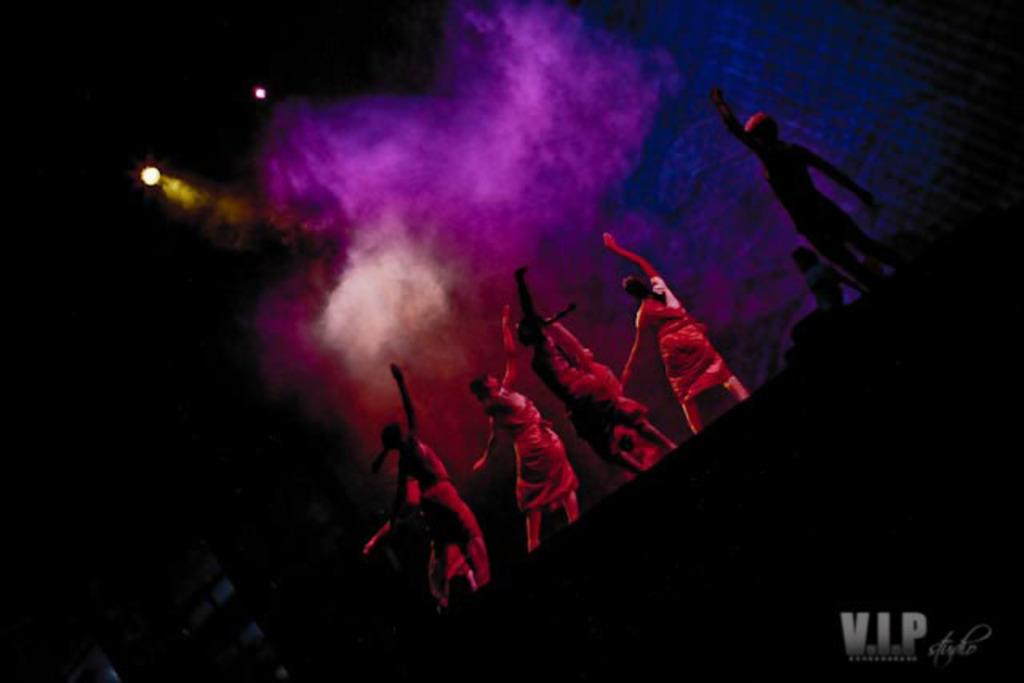What are the people in the image doing? There are many people dancing in the image. Where are the people dancing? The people are dancing on a dais. Can you describe the dais in the image? There is a dais at the bottom of the image. What can be seen in the background of the image? There are lights and smoke visible in the background of the image. How much does the belief in the image weigh? There is no belief present in the image, so it cannot be weighed. Can you describe the texture of the touch in the image? There is no touch present in the image, so it cannot be described in terms of texture. 